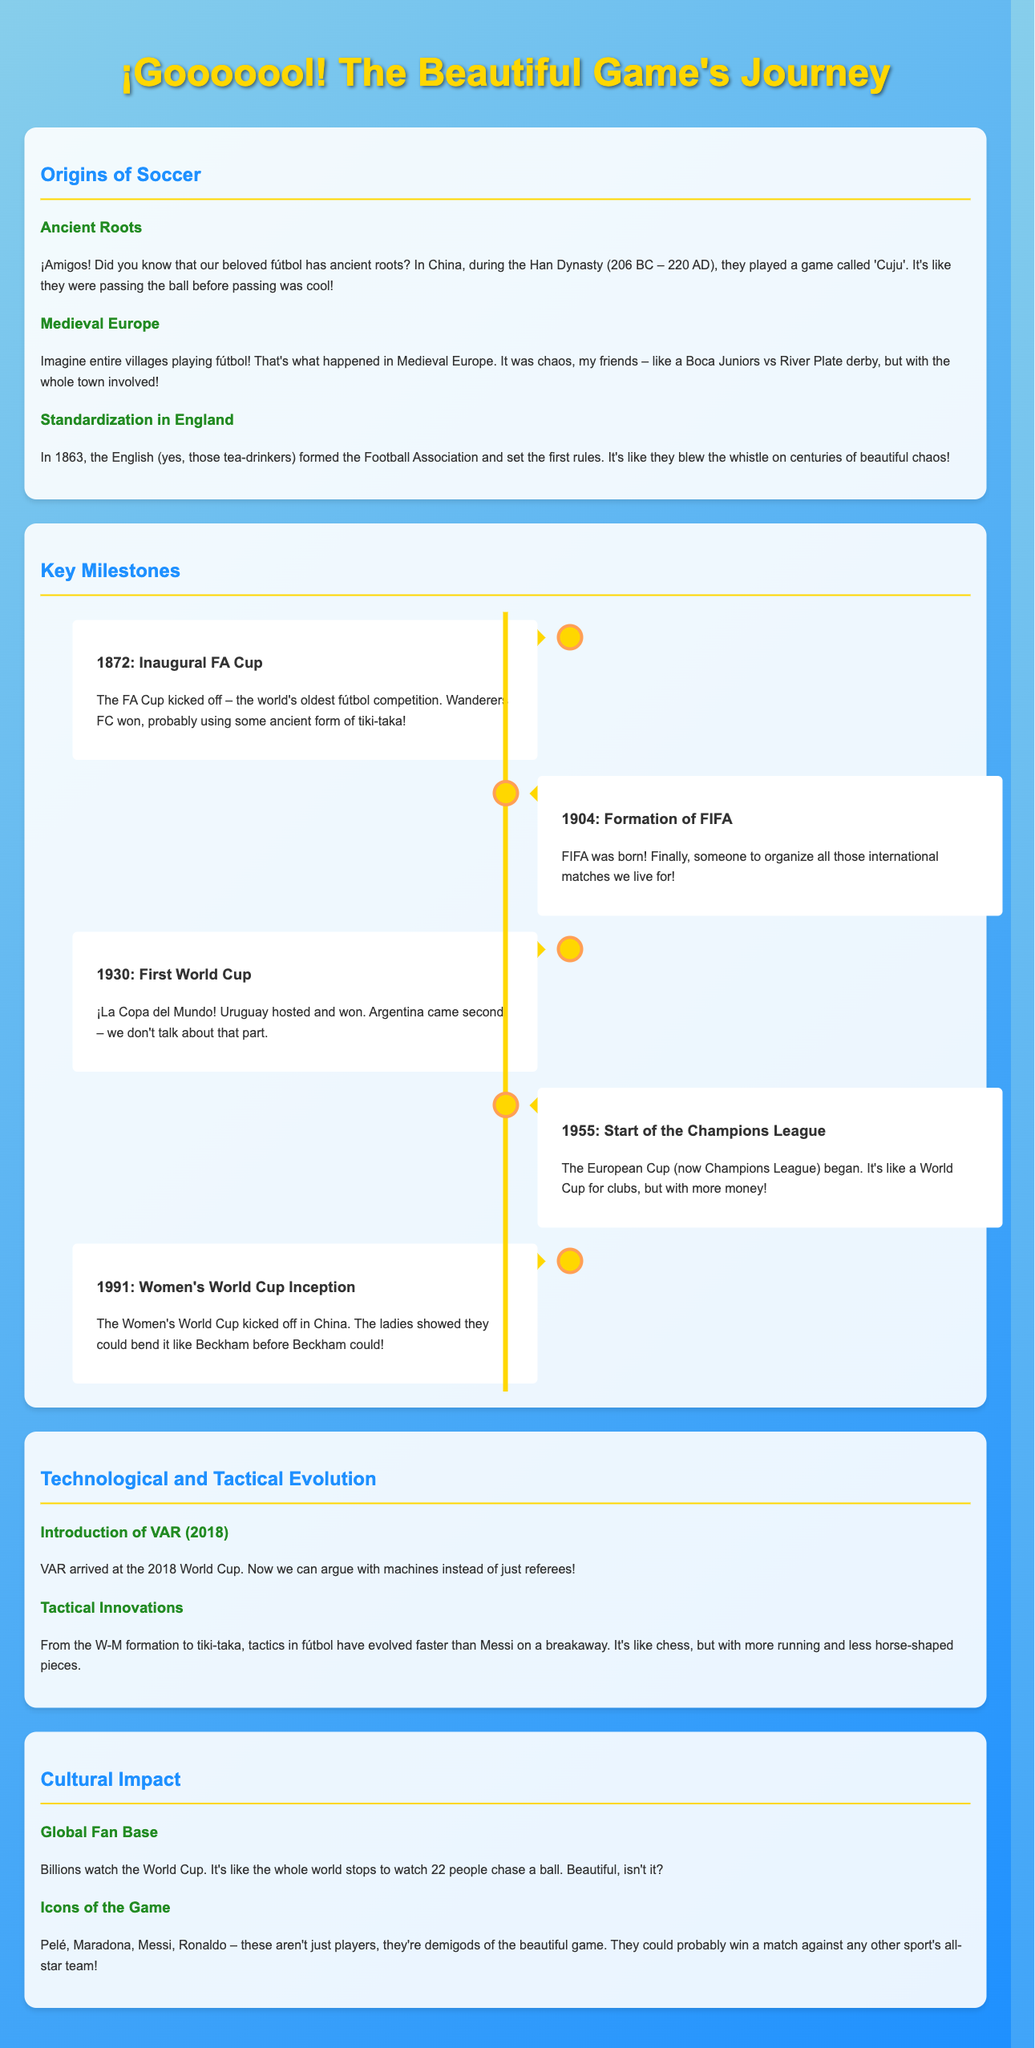What game was played in ancient China during the Han Dynasty? The document mentions 'Cuju' as the game played in ancient China during the Han Dynasty.
Answer: Cuju What significant association was formed in 1863? According to the document, the Football Association was formed in 1863, which is a significant milestone.
Answer: Football Association What year did the first World Cup take place? The document specifies that the first World Cup occurred in 1930.
Answer: 1930 Which club won the inaugural FA Cup in 1872? The document states that Wanderers FC won the inaugural FA Cup in 1872.
Answer: Wanderers FC Who are considered demigods of the beautiful game? The document lists Pelé, Maradona, Messi, and Ronaldo as demigods of fútbol.
Answer: Pelé, Maradona, Messi, Ronaldo How has the tactical evolution of soccer been described? The content describes tactical evolution in fútbol as faster than Messi on a breakaway, highlighting rapid changes over time.
Answer: Faster than Messi on a breakaway What significant technology was introduced at the 2018 World Cup? The document states that VAR (Video Assistant Referee) was introduced at the 2018 World Cup.
Answer: VAR In what year did the Women's World Cup first take place? As highlighted in the document, the Women's World Cup was first held in 1991.
Answer: 1991 Which iconic competition started in 1955? The document states that the European Cup (now Champions League) began in 1955.
Answer: European Cup 